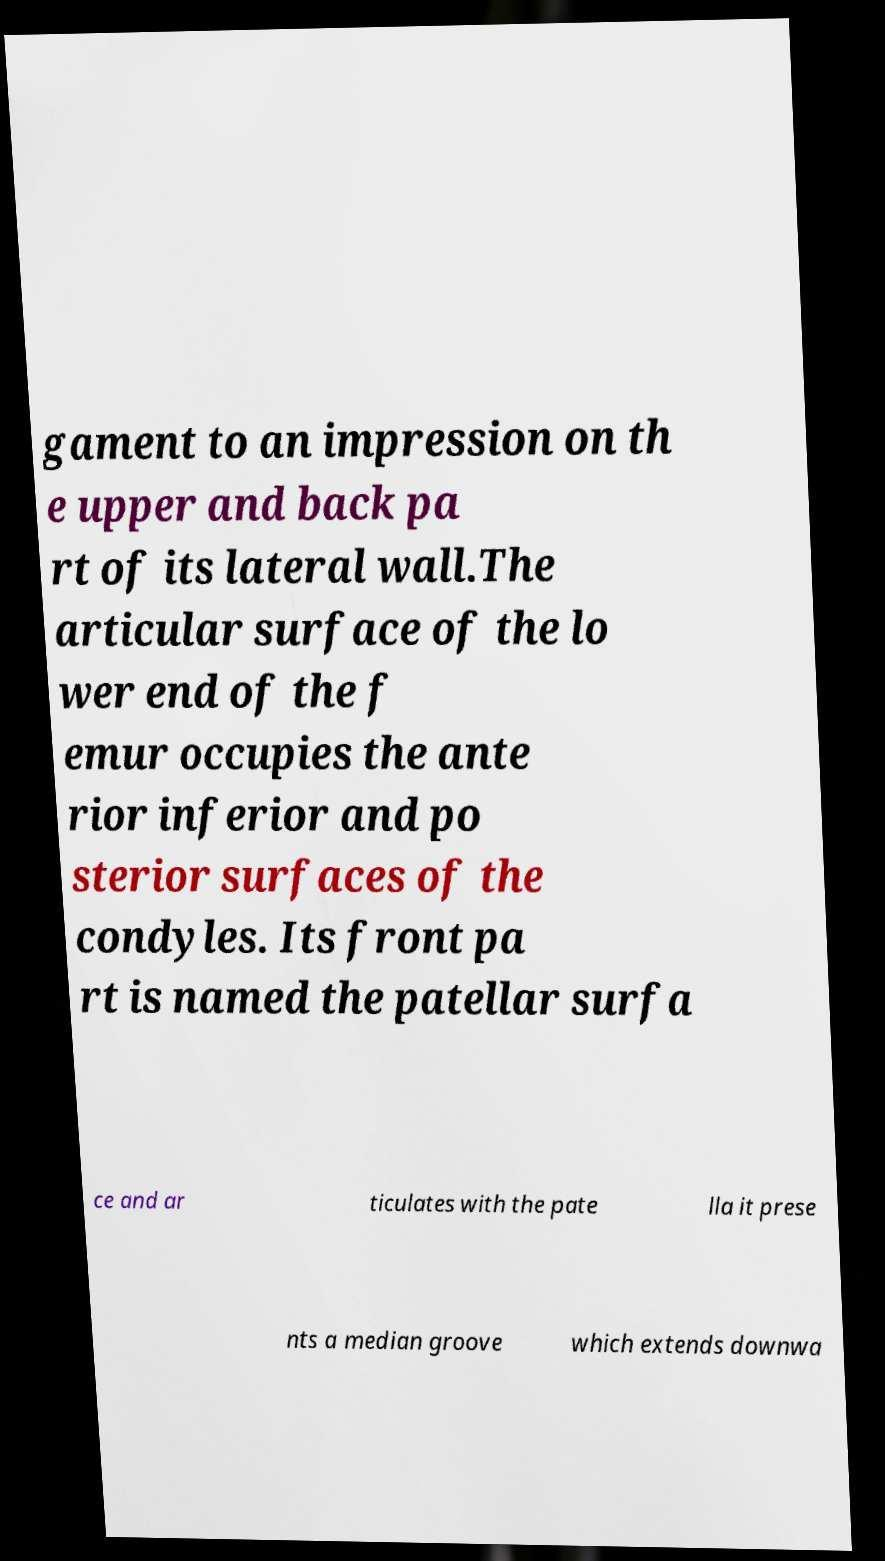There's text embedded in this image that I need extracted. Can you transcribe it verbatim? gament to an impression on th e upper and back pa rt of its lateral wall.The articular surface of the lo wer end of the f emur occupies the ante rior inferior and po sterior surfaces of the condyles. Its front pa rt is named the patellar surfa ce and ar ticulates with the pate lla it prese nts a median groove which extends downwa 